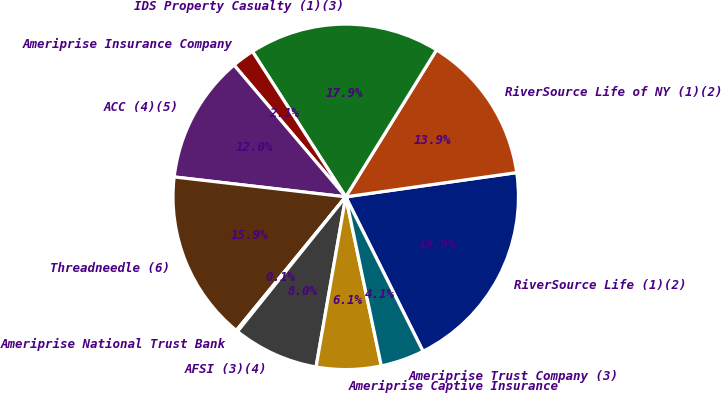Convert chart. <chart><loc_0><loc_0><loc_500><loc_500><pie_chart><fcel>RiverSource Life (1)(2)<fcel>RiverSource Life of NY (1)(2)<fcel>IDS Property Casualty (1)(3)<fcel>Ameriprise Insurance Company<fcel>ACC (4)(5)<fcel>Threadneedle (6)<fcel>Ameriprise National Trust Bank<fcel>AFSI (3)(4)<fcel>Ameriprise Captive Insurance<fcel>Ameriprise Trust Company (3)<nl><fcel>19.86%<fcel>13.95%<fcel>17.89%<fcel>2.11%<fcel>11.97%<fcel>15.92%<fcel>0.14%<fcel>8.03%<fcel>6.05%<fcel>4.08%<nl></chart> 